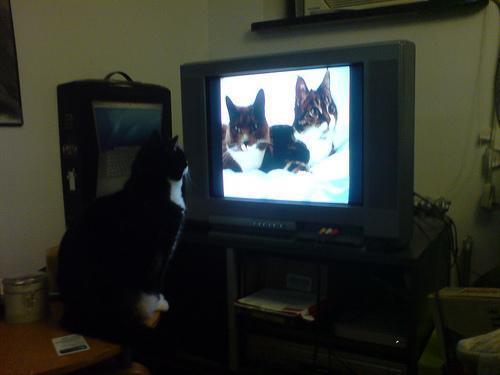How many cats are on the screen?
Give a very brief answer. 2. How many total cats are there?
Give a very brief answer. 3. 